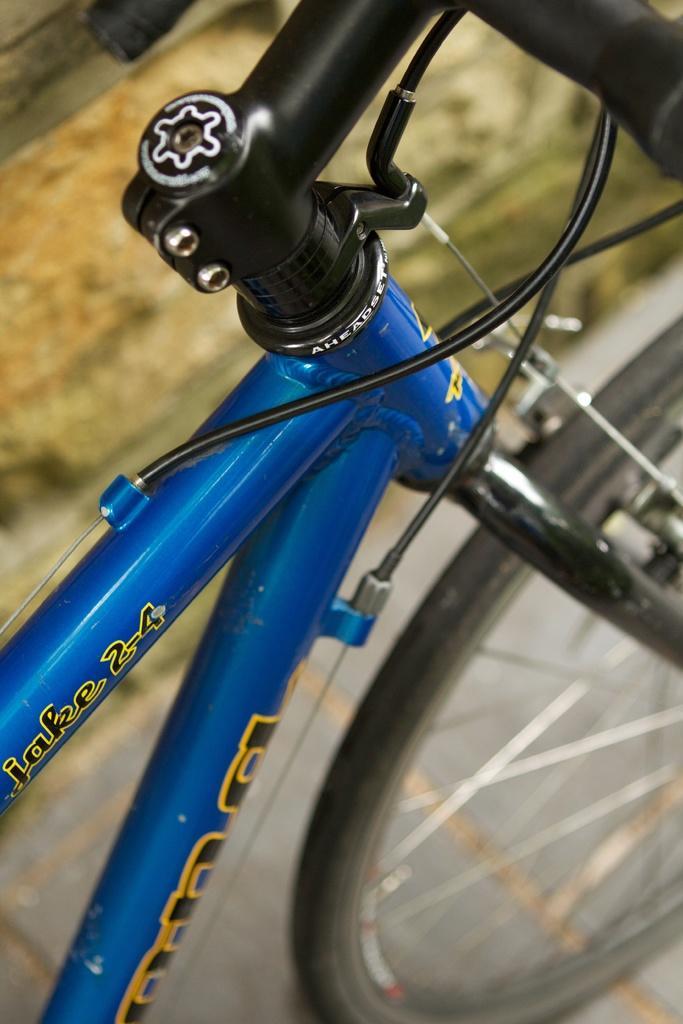Please provide a concise description of this image. This image is taken outdoors. In the middle of the image a bicycle is parked on the road. 